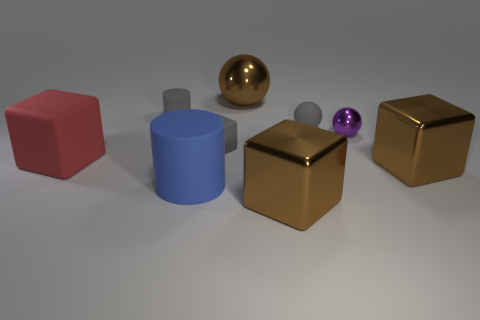Is there a large block of the same color as the big metal sphere?
Ensure brevity in your answer.  Yes. How many objects are either large metal objects that are in front of the large red cube or tiny brown cubes?
Ensure brevity in your answer.  2. What number of tiny yellow cubes are made of the same material as the tiny cylinder?
Offer a very short reply. 0. Are there an equal number of gray rubber cylinders in front of the blue rubber cylinder and gray things?
Provide a succinct answer. No. There is a brown object behind the red cube; how big is it?
Your response must be concise. Large. How many small things are yellow metallic cylinders or blue matte objects?
Your answer should be compact. 0. What is the color of the big thing that is the same shape as the tiny purple metal object?
Your answer should be compact. Brown. Does the gray cylinder have the same size as the red rubber object?
Provide a short and direct response. No. How many objects are brown blocks or brown metal cubes in front of the blue matte cylinder?
Provide a short and direct response. 2. There is a tiny sphere that is on the left side of the metal ball that is in front of the brown sphere; what is its color?
Make the answer very short. Gray. 